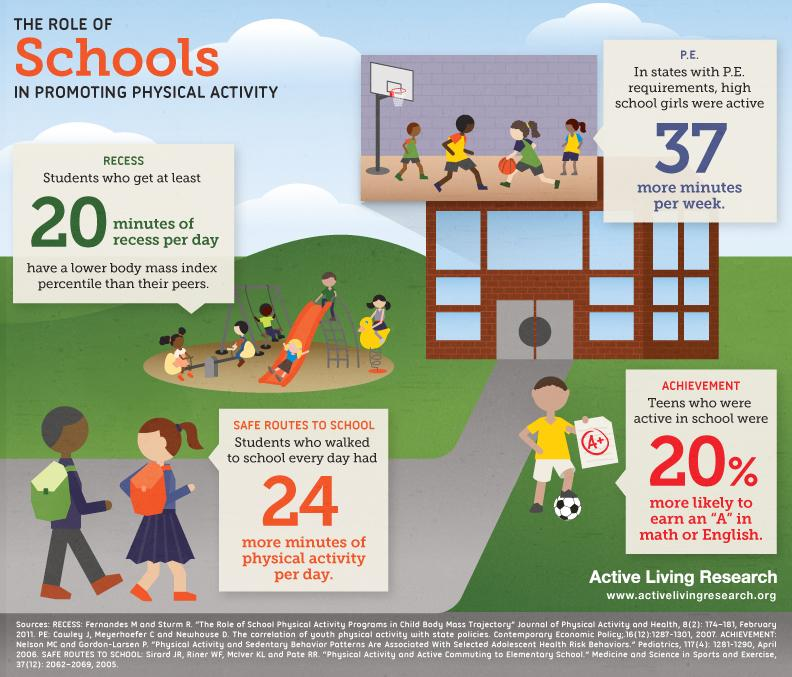Specify some key components in this picture. In the United States, states that have physical education (P.E.) requirements tend to have more active high school girls than states that do not have such requirements. 